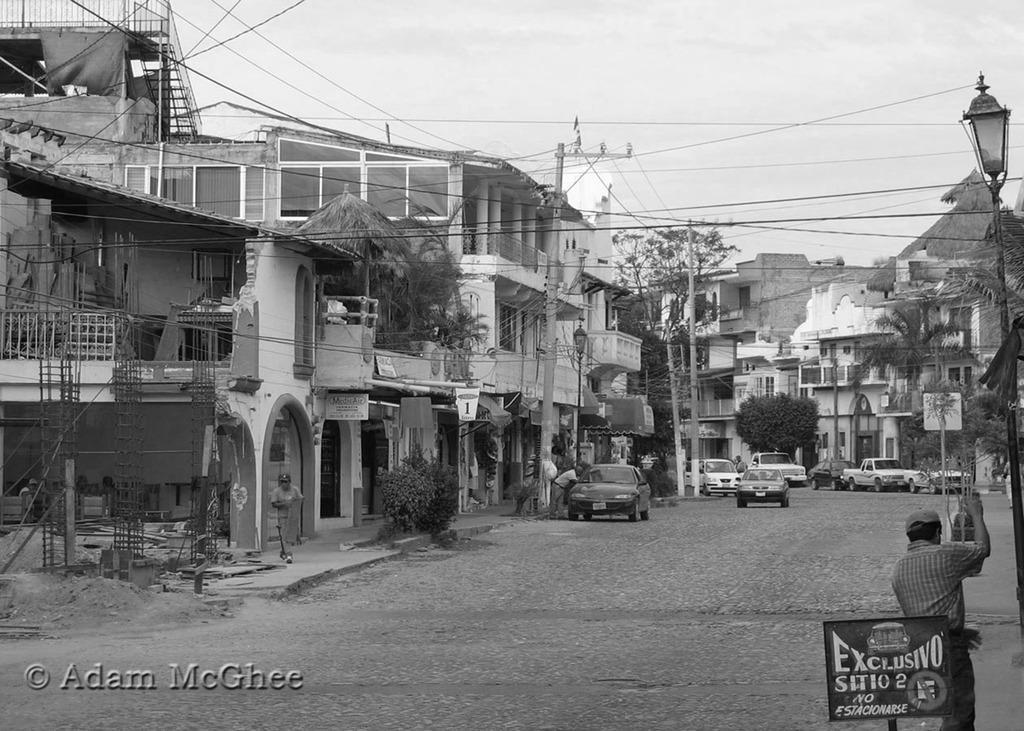Could you give a brief overview of what you see in this image? In this image there are buildings and trees and their vehicles on the road. On the left side of the image there is a person walking on the footpath. On the right side of the image there is a man on the footpath and there is a board and there is text on the board and there are wires on the poles. On the left side of the image there are pillars. At the top there is sky. At the bottom there is a road. At the bottom left there is text. 